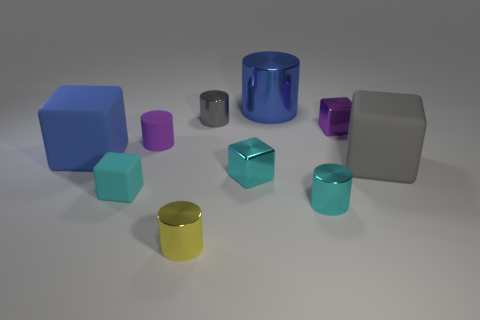Subtract all purple cylinders. How many cylinders are left? 4 Subtract all brown balls. How many cyan blocks are left? 2 Subtract all gray cylinders. How many cylinders are left? 4 Subtract 2 cylinders. How many cylinders are left? 3 Subtract all gray cylinders. Subtract all red blocks. How many cylinders are left? 4 Subtract all big shiny cylinders. Subtract all cyan shiny cubes. How many objects are left? 8 Add 7 small cyan cubes. How many small cyan cubes are left? 9 Add 5 tiny metallic cubes. How many tiny metallic cubes exist? 7 Subtract 1 gray cylinders. How many objects are left? 9 